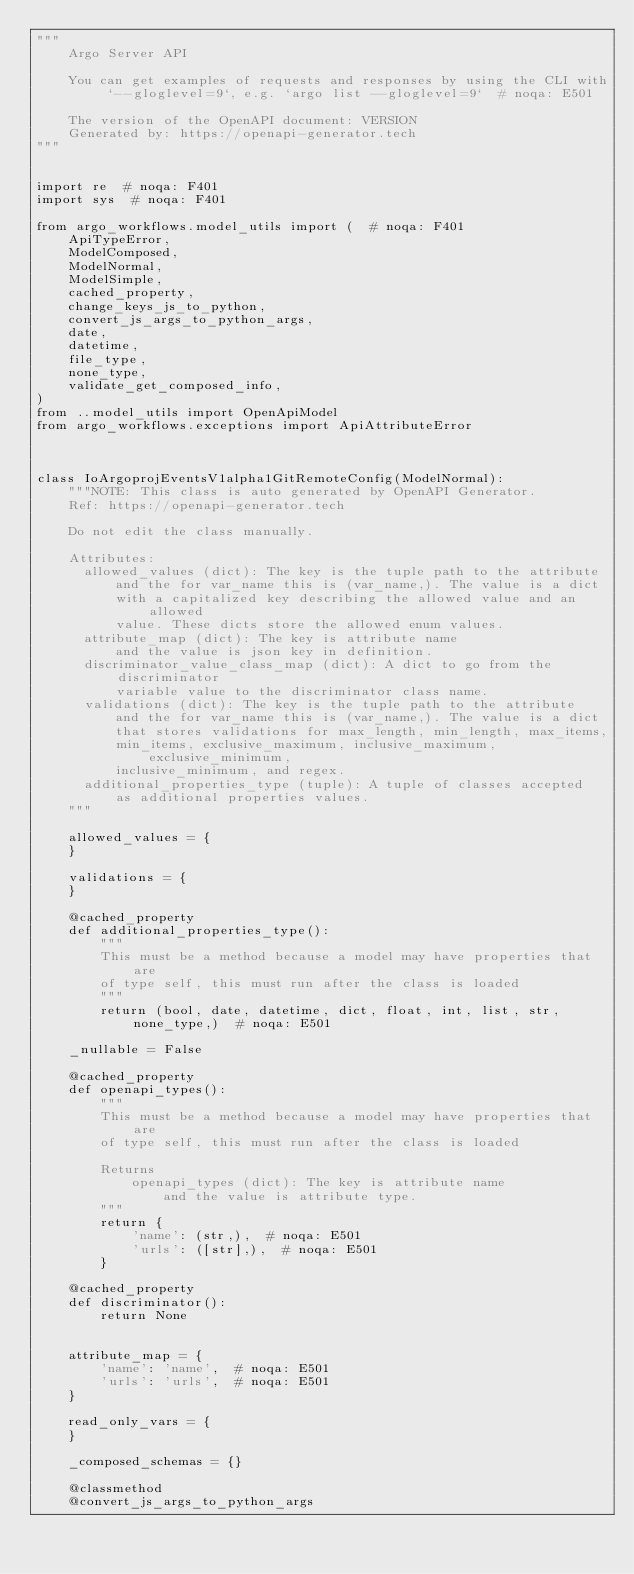<code> <loc_0><loc_0><loc_500><loc_500><_Python_>"""
    Argo Server API

    You can get examples of requests and responses by using the CLI with `--gloglevel=9`, e.g. `argo list --gloglevel=9`  # noqa: E501

    The version of the OpenAPI document: VERSION
    Generated by: https://openapi-generator.tech
"""


import re  # noqa: F401
import sys  # noqa: F401

from argo_workflows.model_utils import (  # noqa: F401
    ApiTypeError,
    ModelComposed,
    ModelNormal,
    ModelSimple,
    cached_property,
    change_keys_js_to_python,
    convert_js_args_to_python_args,
    date,
    datetime,
    file_type,
    none_type,
    validate_get_composed_info,
)
from ..model_utils import OpenApiModel
from argo_workflows.exceptions import ApiAttributeError



class IoArgoprojEventsV1alpha1GitRemoteConfig(ModelNormal):
    """NOTE: This class is auto generated by OpenAPI Generator.
    Ref: https://openapi-generator.tech

    Do not edit the class manually.

    Attributes:
      allowed_values (dict): The key is the tuple path to the attribute
          and the for var_name this is (var_name,). The value is a dict
          with a capitalized key describing the allowed value and an allowed
          value. These dicts store the allowed enum values.
      attribute_map (dict): The key is attribute name
          and the value is json key in definition.
      discriminator_value_class_map (dict): A dict to go from the discriminator
          variable value to the discriminator class name.
      validations (dict): The key is the tuple path to the attribute
          and the for var_name this is (var_name,). The value is a dict
          that stores validations for max_length, min_length, max_items,
          min_items, exclusive_maximum, inclusive_maximum, exclusive_minimum,
          inclusive_minimum, and regex.
      additional_properties_type (tuple): A tuple of classes accepted
          as additional properties values.
    """

    allowed_values = {
    }

    validations = {
    }

    @cached_property
    def additional_properties_type():
        """
        This must be a method because a model may have properties that are
        of type self, this must run after the class is loaded
        """
        return (bool, date, datetime, dict, float, int, list, str, none_type,)  # noqa: E501

    _nullable = False

    @cached_property
    def openapi_types():
        """
        This must be a method because a model may have properties that are
        of type self, this must run after the class is loaded

        Returns
            openapi_types (dict): The key is attribute name
                and the value is attribute type.
        """
        return {
            'name': (str,),  # noqa: E501
            'urls': ([str],),  # noqa: E501
        }

    @cached_property
    def discriminator():
        return None


    attribute_map = {
        'name': 'name',  # noqa: E501
        'urls': 'urls',  # noqa: E501
    }

    read_only_vars = {
    }

    _composed_schemas = {}

    @classmethod
    @convert_js_args_to_python_args</code> 